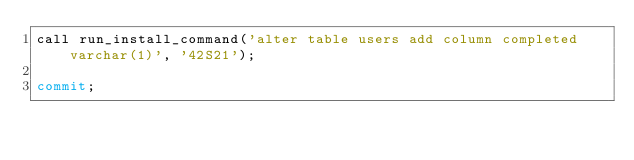Convert code to text. <code><loc_0><loc_0><loc_500><loc_500><_SQL_>call run_install_command('alter table users add column completed varchar(1)', '42S21');

commit;</code> 